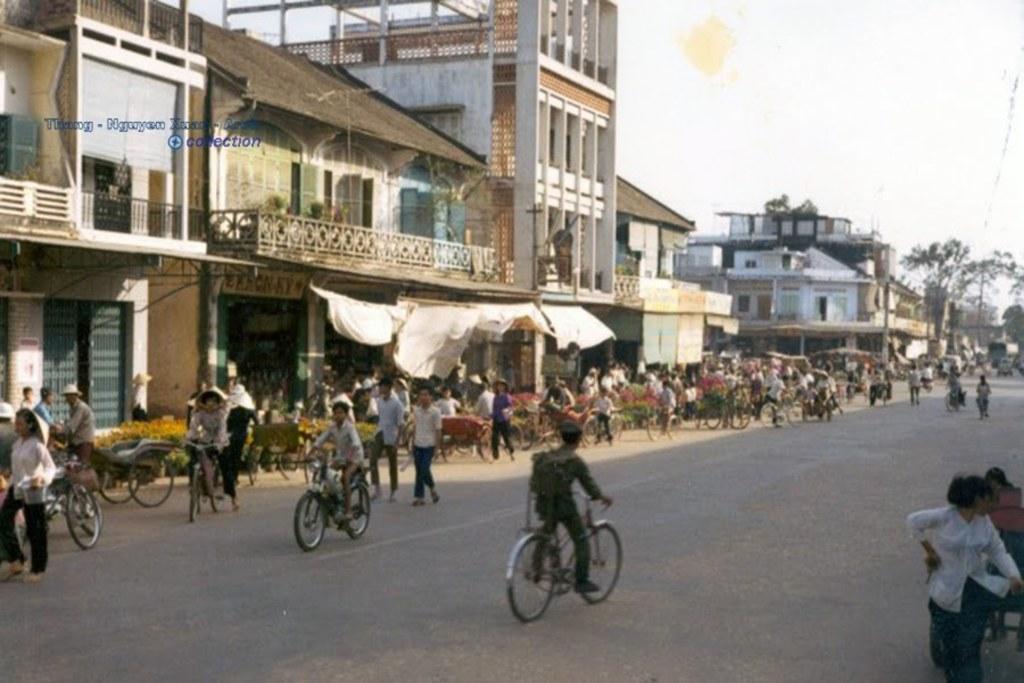How would you summarize this image in a sentence or two? In the image there are many stalls kept beside the road and many vehicles are moving on the road, behind the stalls there are many buildings and on the right side there is a tree. 